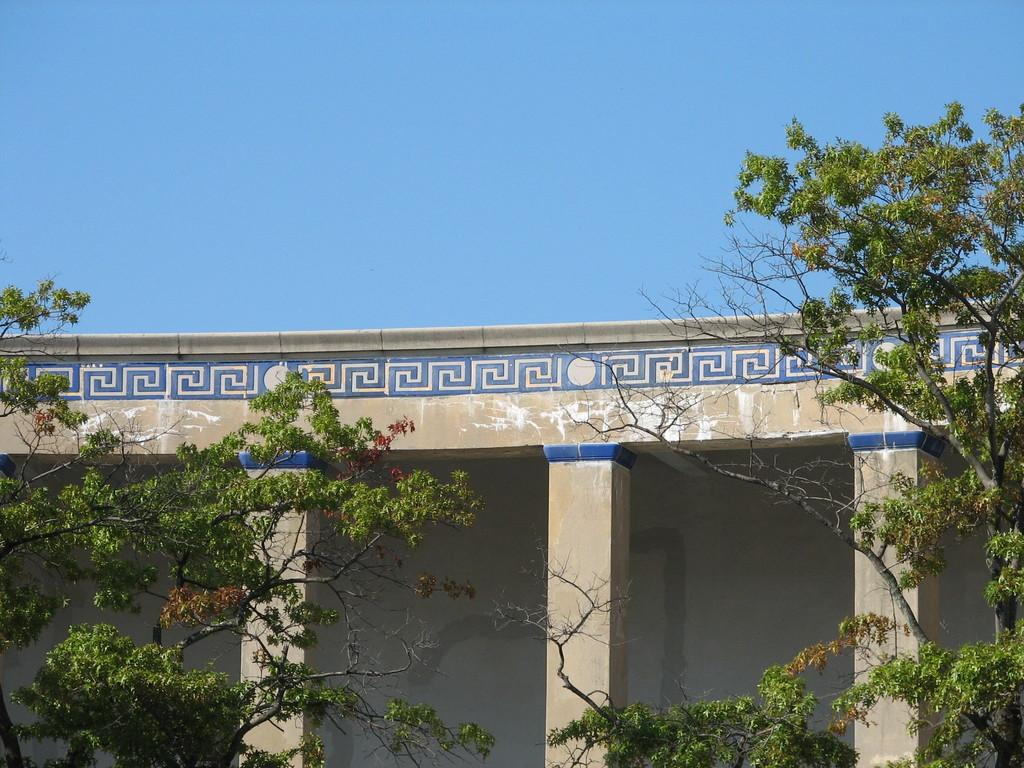What type of structure is visible in the image? There is a building in the image. What can be seen in front of the building? Trees are present in front of the building. What is visible above the building? The sky is visible above the building. What type of rhythm can be heard coming from the building in the image? There is no indication of sound or rhythm in the image, as it only shows a building with trees in front and the sky above. 